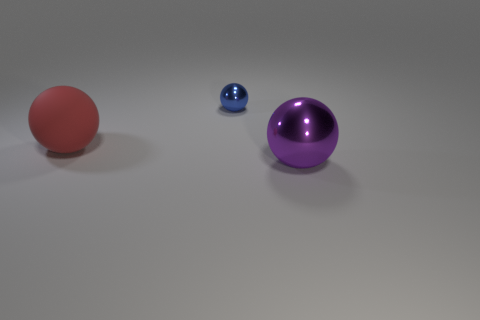There is a large purple thing; is its shape the same as the shiny thing that is behind the matte thing?
Offer a terse response. Yes. Do the blue ball and the purple thing in front of the tiny blue metallic object have the same material?
Provide a short and direct response. Yes. There is a big thing left of the metallic object that is behind the large object behind the purple shiny ball; what is its color?
Your response must be concise. Red. Is there any other thing that has the same size as the blue metallic sphere?
Your response must be concise. No. What is the color of the small sphere?
Keep it short and to the point. Blue. The thing in front of the large thing that is left of the metal sphere that is behind the big purple thing is what shape?
Provide a succinct answer. Sphere. Are there more objects that are to the left of the small blue object than tiny blue spheres that are left of the large red ball?
Your answer should be compact. Yes. Are there any metal things left of the large metallic sphere?
Offer a very short reply. Yes. The ball that is right of the red object and left of the purple object is made of what material?
Make the answer very short. Metal. The other big matte thing that is the same shape as the large purple thing is what color?
Keep it short and to the point. Red. 